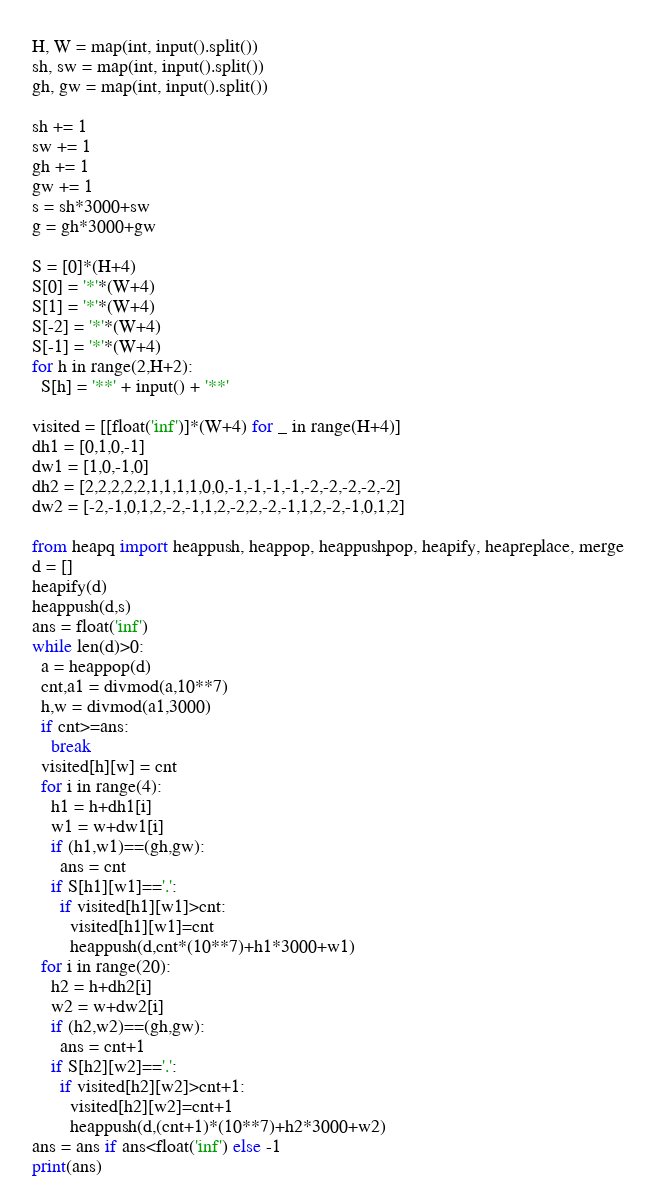<code> <loc_0><loc_0><loc_500><loc_500><_Cython_>H, W = map(int, input().split())
sh, sw = map(int, input().split())
gh, gw = map(int, input().split())

sh += 1
sw += 1
gh += 1
gw += 1
s = sh*3000+sw
g = gh*3000+gw

S = [0]*(H+4)
S[0] = '*'*(W+4)
S[1] = '*'*(W+4)
S[-2] = '*'*(W+4)
S[-1] = '*'*(W+4)
for h in range(2,H+2):
  S[h] = '**' + input() + '**'

visited = [[float('inf')]*(W+4) for _ in range(H+4)]
dh1 = [0,1,0,-1]
dw1 = [1,0,-1,0]
dh2 = [2,2,2,2,2,1,1,1,1,0,0,-1,-1,-1,-1,-2,-2,-2,-2,-2]
dw2 = [-2,-1,0,1,2,-2,-1,1,2,-2,2,-2,-1,1,2,-2,-1,0,1,2]

from heapq import heappush, heappop, heappushpop, heapify, heapreplace, merge
d = []
heapify(d)
heappush(d,s)
ans = float('inf')
while len(d)>0:
  a = heappop(d)
  cnt,a1 = divmod(a,10**7)
  h,w = divmod(a1,3000)
  if cnt>=ans:
    break
  visited[h][w] = cnt
  for i in range(4):
    h1 = h+dh1[i]
    w1 = w+dw1[i]
    if (h1,w1)==(gh,gw):
      ans = cnt
    if S[h1][w1]=='.':
      if visited[h1][w1]>cnt:
        visited[h1][w1]=cnt
        heappush(d,cnt*(10**7)+h1*3000+w1)
  for i in range(20):
    h2 = h+dh2[i]
    w2 = w+dw2[i]
    if (h2,w2)==(gh,gw):
      ans = cnt+1
    if S[h2][w2]=='.':
      if visited[h2][w2]>cnt+1:
        visited[h2][w2]=cnt+1
        heappush(d,(cnt+1)*(10**7)+h2*3000+w2)
ans = ans if ans<float('inf') else -1
print(ans)
</code> 